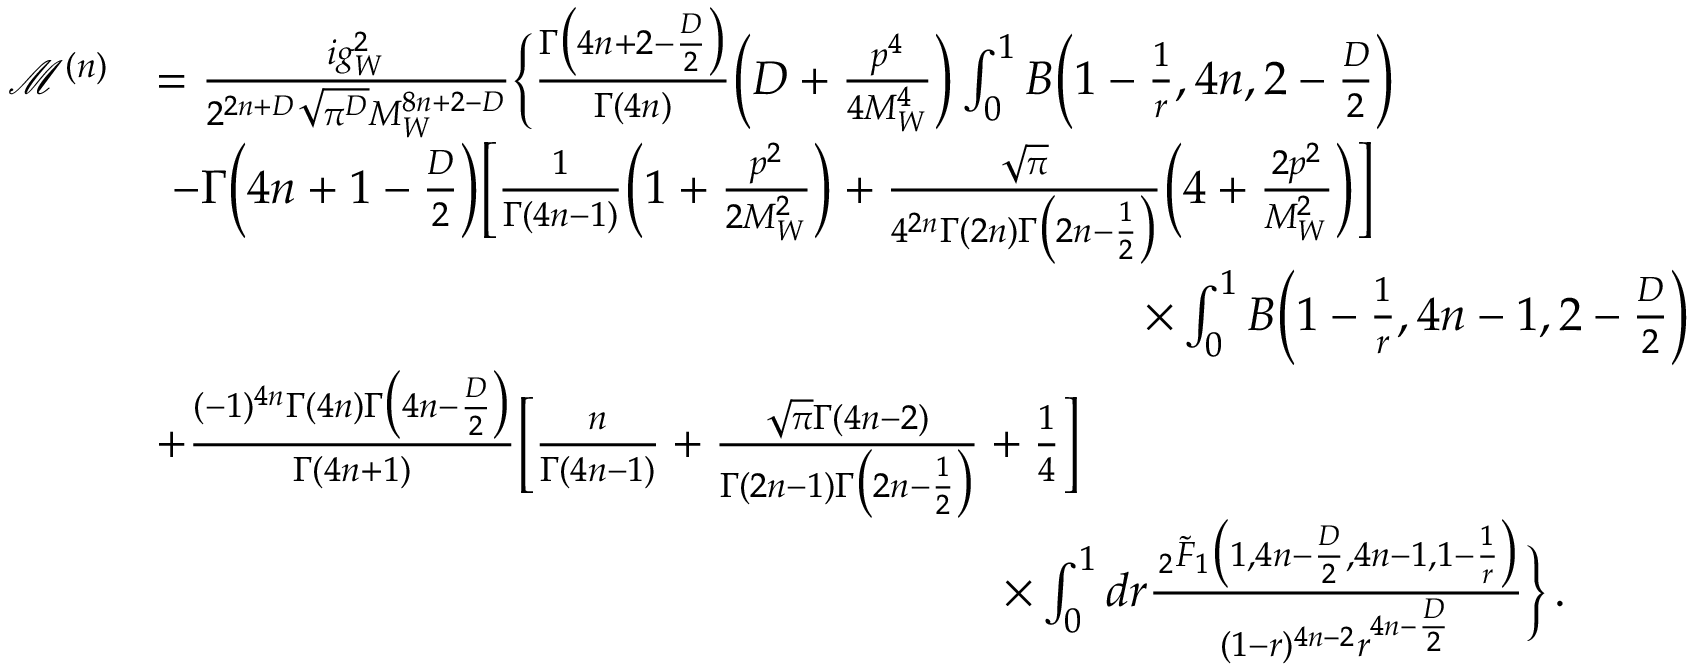Convert formula to latex. <formula><loc_0><loc_0><loc_500><loc_500>\begin{array} { r l } { \mathcal { M } ^ { ( n ) } } & { = \frac { i g _ { W } ^ { 2 } } { 2 ^ { 2 n + D } \sqrt { \pi ^ { D } } M _ { W } ^ { 8 n + 2 - D } } \left \{ \frac { \Gamma \left ( 4 n + 2 - \frac { D } { 2 } \right ) } { \Gamma ( 4 n ) } \left ( D + \frac { p ^ { 4 } } { 4 M _ { W } ^ { 4 } } \right ) \int _ { 0 } ^ { 1 } B \left ( 1 - \frac { 1 } { r } , 4 n , 2 - \frac { D } { 2 } \right ) } \\ & { \, - \Gamma \left ( 4 n + 1 - \frac { D } { 2 } \right ) \left [ \frac { 1 } { \Gamma ( 4 n - 1 ) } \left ( 1 + \frac { p ^ { 2 } } { 2 M _ { W } ^ { 2 } } \right ) + \frac { \sqrt { \pi } } { 4 ^ { 2 n } \Gamma ( 2 n ) \Gamma \left ( 2 n - \frac { 1 } { 2 } \right ) } \left ( 4 + \frac { 2 p ^ { 2 } } { M _ { W } ^ { 2 } } \right ) \right ] } \\ & { \quad \times \int _ { 0 } ^ { 1 } B \left ( 1 - \frac { 1 } { r } , 4 n - 1 , 2 - \frac { D } { 2 } \right ) } \\ & { + \frac { ( - 1 ) ^ { 4 n } \Gamma ( 4 n ) \Gamma \left ( 4 n - \frac { D } { 2 } \right ) } { \Gamma ( 4 n + 1 ) } \left [ \frac { n } { \Gamma ( 4 n - 1 ) } + \frac { \sqrt { \pi } \Gamma ( 4 n - 2 ) } { \Gamma ( 2 n - 1 ) \Gamma \left ( 2 n - \frac { 1 } { 2 } \right ) } + \frac { 1 } { 4 } \right ] } \\ & { \quad \times \int _ { 0 } ^ { 1 } d r \frac { \, _ { 2 } \tilde { F } _ { 1 } \left ( 1 , 4 n - \frac { D } { 2 } , 4 n - 1 , 1 - \frac { 1 } { r } \right ) } { ( 1 - r ) ^ { 4 n - 2 } r ^ { 4 n - \frac { D } { 2 } } } \right \} \, . } \end{array}</formula> 